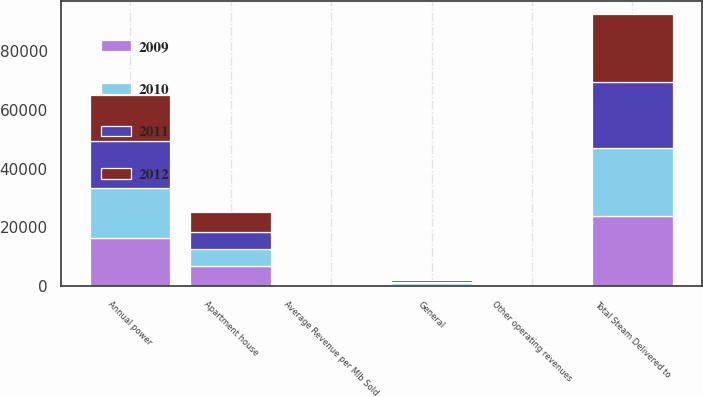<chart> <loc_0><loc_0><loc_500><loc_500><stacked_bar_chart><ecel><fcel>General<fcel>Apartment house<fcel>Annual power<fcel>Total Steam Delivered to<fcel>Other operating revenues<fcel>Average Revenue per Mlb Sold<nl><fcel>2009<fcel>533<fcel>6936<fcel>16507<fcel>23976<fcel>30<fcel>28.24<nl><fcel>2012<fcel>544<fcel>6725<fcel>15748<fcel>23017<fcel>22<fcel>27.76<nl><fcel>2010<fcel>515<fcel>5748<fcel>16767<fcel>23030<fcel>16<fcel>27.79<nl><fcel>2011<fcel>519<fcel>5779<fcel>16024<fcel>22322<fcel>7<fcel>30.91<nl></chart> 